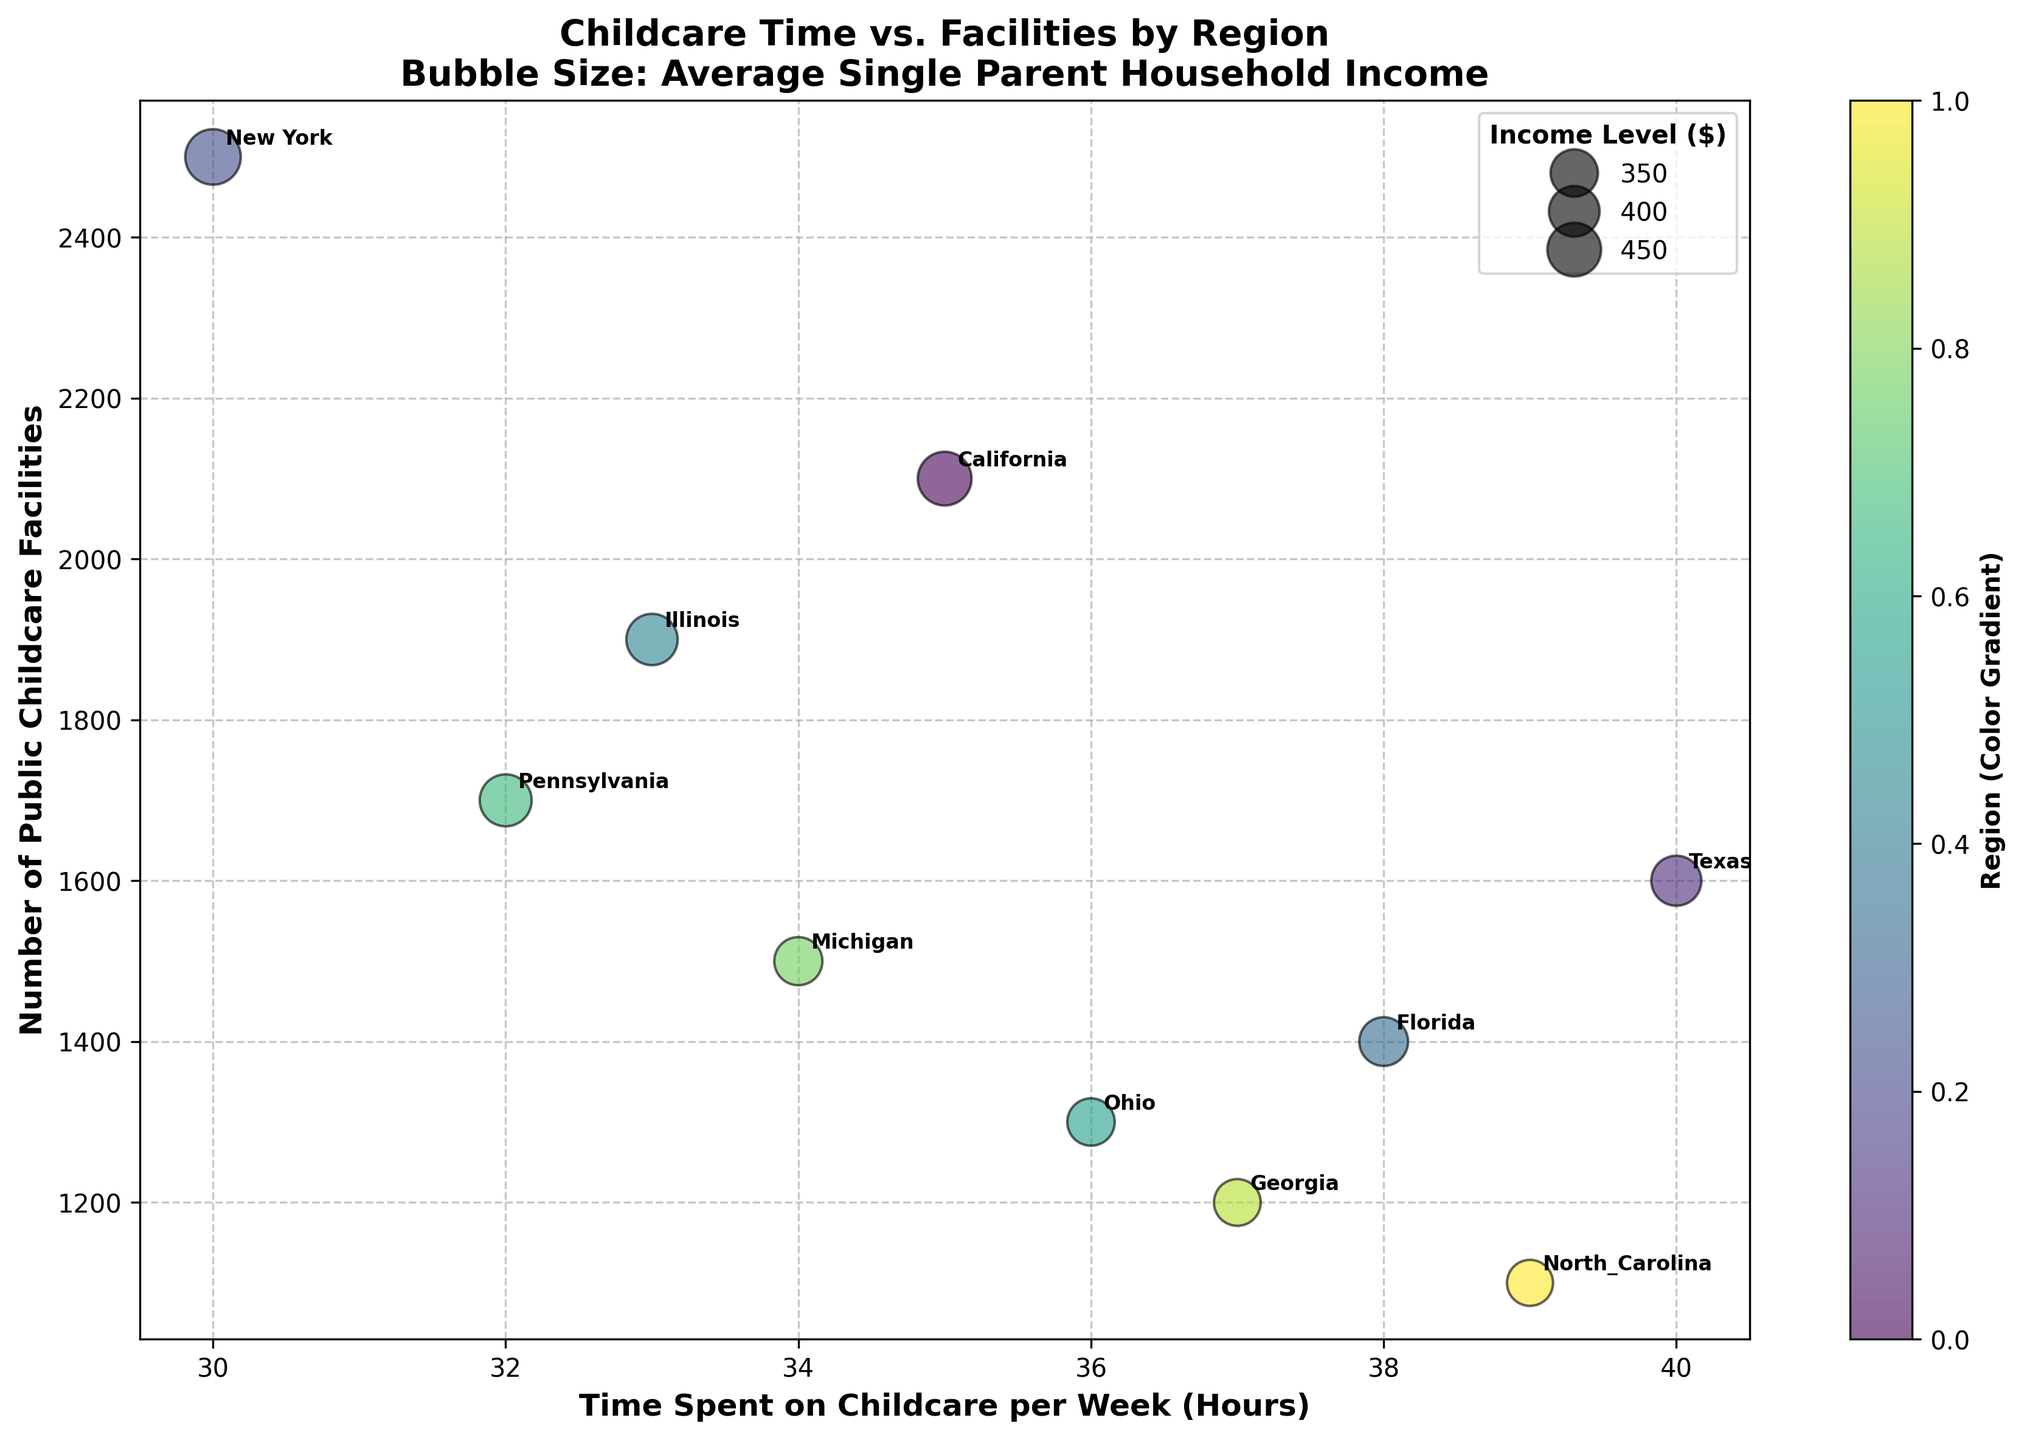What is the title of the figure? The title of the figure is located at the top and generally provides a summary of what the figure is about. Here, the title is "Childcare Time vs. Facilities by Region\nBubble Size: Average Single Parent Household Income."
Answer: Childcare Time vs. Facilities by Region Which region has the highest number of public childcare facilities? To determine which region has the highest number of public childcare facilities, we look for the data point that is highest on the y-axis. In this case, New York has the highest value on the y-axis.
Answer: New York What color gradient is used to represent the regions? The figure description mentions the use of a color gradient represented by the color bar at the side. The color used here is "viridis."
Answer: viridis Which region has the largest bubble size and thus the highest average single-parent household income? The bubble size correlates with the income level, so we need to identify the largest bubble. New York has the largest bubble, indicating the highest income level.
Answer: New York How many regions spend 35 hours or more on childcare per week? Checking the x-axis, we identify the data points that are 35 or higher. The regions meeting this criterion are California, Texas, Florida, Ohio, Georgia, and North Carolina.
Answer: 6 Which regions have fewer than 1500 public childcare facilities and how much time are they spending on childcare per week? From the y-axis, we identify regions below 1500, which are Ohio, Georgia, and North Carolina. Their corresponding weekly childcare times are 36, 37, and 39 hours, respectively.
Answer: Ohio (36), Georgia (37), North Carolina (39) What is the range in the number of public childcare facilities across all regions? To determine the range, we subtract the minimum number of facilities from the maximum. The maximum is 2500 (New York) and the minimum is 1100 (North Carolina), so the range is 2500 - 1100.
Answer: 1400 Compare the average income levels between Illinois and Georgia. Which one is higher? By examining the bubble sizes for Illinois ($41,000) and Georgia ($34,000), it's evident that Illinois has a higher average income level.
Answer: Illinois What is the average number of public childcare facilities for the listed regions? The sum of the facilities for all regions is (2100 + 1600 + 2500 + 1400 + 1900 + 1300 + 1700 + 1500 + 1200 + 1100) = 16300, and there are 10 regions. So, the average is 16300/10.
Answer: 1630 Which region spends the least amount of time on childcare per week, and how many public childcare facilities do they have? Looking at the x-axis, New York spends the least time on childcare per week (30 hours). New York has 2500 public childcare facilities.
Answer: New York (30 hours, 2500 facilities) 